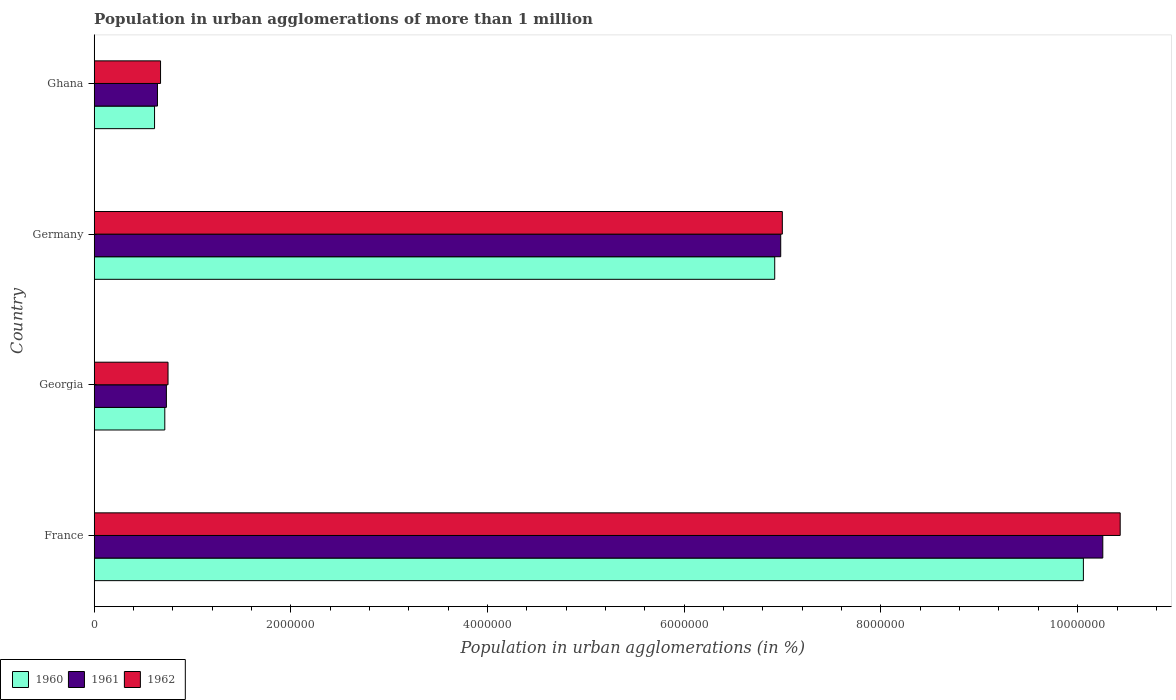How many different coloured bars are there?
Offer a terse response. 3. How many groups of bars are there?
Provide a succinct answer. 4. Are the number of bars per tick equal to the number of legend labels?
Make the answer very short. Yes. What is the population in urban agglomerations in 1962 in Georgia?
Your answer should be very brief. 7.51e+05. Across all countries, what is the maximum population in urban agglomerations in 1961?
Offer a very short reply. 1.03e+07. Across all countries, what is the minimum population in urban agglomerations in 1961?
Offer a terse response. 6.43e+05. What is the total population in urban agglomerations in 1961 in the graph?
Your answer should be compact. 1.86e+07. What is the difference between the population in urban agglomerations in 1960 in France and that in Georgia?
Offer a terse response. 9.34e+06. What is the difference between the population in urban agglomerations in 1962 in France and the population in urban agglomerations in 1961 in Georgia?
Offer a very short reply. 9.70e+06. What is the average population in urban agglomerations in 1960 per country?
Provide a short and direct response. 4.58e+06. What is the difference between the population in urban agglomerations in 1961 and population in urban agglomerations in 1962 in Georgia?
Offer a terse response. -1.66e+04. What is the ratio of the population in urban agglomerations in 1962 in Germany to that in Ghana?
Your response must be concise. 10.37. Is the population in urban agglomerations in 1961 in Georgia less than that in Germany?
Your answer should be very brief. Yes. What is the difference between the highest and the second highest population in urban agglomerations in 1960?
Your answer should be compact. 3.14e+06. What is the difference between the highest and the lowest population in urban agglomerations in 1960?
Give a very brief answer. 9.44e+06. Is it the case that in every country, the sum of the population in urban agglomerations in 1960 and population in urban agglomerations in 1961 is greater than the population in urban agglomerations in 1962?
Your answer should be very brief. Yes. Are all the bars in the graph horizontal?
Your response must be concise. Yes. How many countries are there in the graph?
Offer a terse response. 4. Are the values on the major ticks of X-axis written in scientific E-notation?
Your answer should be compact. No. Does the graph contain any zero values?
Your answer should be very brief. No. Where does the legend appear in the graph?
Provide a succinct answer. Bottom left. How are the legend labels stacked?
Your response must be concise. Horizontal. What is the title of the graph?
Your answer should be compact. Population in urban agglomerations of more than 1 million. Does "1980" appear as one of the legend labels in the graph?
Offer a very short reply. No. What is the label or title of the X-axis?
Make the answer very short. Population in urban agglomerations (in %). What is the label or title of the Y-axis?
Your answer should be very brief. Country. What is the Population in urban agglomerations (in %) in 1960 in France?
Your response must be concise. 1.01e+07. What is the Population in urban agglomerations (in %) of 1961 in France?
Offer a very short reply. 1.03e+07. What is the Population in urban agglomerations (in %) in 1962 in France?
Keep it short and to the point. 1.04e+07. What is the Population in urban agglomerations (in %) of 1960 in Georgia?
Keep it short and to the point. 7.18e+05. What is the Population in urban agglomerations (in %) in 1961 in Georgia?
Give a very brief answer. 7.34e+05. What is the Population in urban agglomerations (in %) in 1962 in Georgia?
Keep it short and to the point. 7.51e+05. What is the Population in urban agglomerations (in %) in 1960 in Germany?
Make the answer very short. 6.92e+06. What is the Population in urban agglomerations (in %) in 1961 in Germany?
Your answer should be very brief. 6.98e+06. What is the Population in urban agglomerations (in %) in 1962 in Germany?
Keep it short and to the point. 7.00e+06. What is the Population in urban agglomerations (in %) of 1960 in Ghana?
Your response must be concise. 6.14e+05. What is the Population in urban agglomerations (in %) in 1961 in Ghana?
Your answer should be very brief. 6.43e+05. What is the Population in urban agglomerations (in %) in 1962 in Ghana?
Keep it short and to the point. 6.75e+05. Across all countries, what is the maximum Population in urban agglomerations (in %) in 1960?
Offer a terse response. 1.01e+07. Across all countries, what is the maximum Population in urban agglomerations (in %) of 1961?
Your answer should be compact. 1.03e+07. Across all countries, what is the maximum Population in urban agglomerations (in %) in 1962?
Make the answer very short. 1.04e+07. Across all countries, what is the minimum Population in urban agglomerations (in %) of 1960?
Offer a terse response. 6.14e+05. Across all countries, what is the minimum Population in urban agglomerations (in %) in 1961?
Provide a succinct answer. 6.43e+05. Across all countries, what is the minimum Population in urban agglomerations (in %) of 1962?
Your response must be concise. 6.75e+05. What is the total Population in urban agglomerations (in %) in 1960 in the graph?
Offer a terse response. 1.83e+07. What is the total Population in urban agglomerations (in %) of 1961 in the graph?
Make the answer very short. 1.86e+07. What is the total Population in urban agglomerations (in %) in 1962 in the graph?
Keep it short and to the point. 1.89e+07. What is the difference between the Population in urban agglomerations (in %) in 1960 in France and that in Georgia?
Your answer should be compact. 9.34e+06. What is the difference between the Population in urban agglomerations (in %) of 1961 in France and that in Georgia?
Your answer should be very brief. 9.52e+06. What is the difference between the Population in urban agglomerations (in %) in 1962 in France and that in Georgia?
Keep it short and to the point. 9.68e+06. What is the difference between the Population in urban agglomerations (in %) in 1960 in France and that in Germany?
Keep it short and to the point. 3.14e+06. What is the difference between the Population in urban agglomerations (in %) of 1961 in France and that in Germany?
Your answer should be very brief. 3.28e+06. What is the difference between the Population in urban agglomerations (in %) in 1962 in France and that in Germany?
Offer a very short reply. 3.44e+06. What is the difference between the Population in urban agglomerations (in %) in 1960 in France and that in Ghana?
Offer a very short reply. 9.44e+06. What is the difference between the Population in urban agglomerations (in %) in 1961 in France and that in Ghana?
Your response must be concise. 9.61e+06. What is the difference between the Population in urban agglomerations (in %) of 1962 in France and that in Ghana?
Your answer should be very brief. 9.76e+06. What is the difference between the Population in urban agglomerations (in %) in 1960 in Georgia and that in Germany?
Provide a succinct answer. -6.20e+06. What is the difference between the Population in urban agglomerations (in %) of 1961 in Georgia and that in Germany?
Your answer should be very brief. -6.25e+06. What is the difference between the Population in urban agglomerations (in %) in 1962 in Georgia and that in Germany?
Provide a succinct answer. -6.25e+06. What is the difference between the Population in urban agglomerations (in %) in 1960 in Georgia and that in Ghana?
Offer a terse response. 1.04e+05. What is the difference between the Population in urban agglomerations (in %) of 1961 in Georgia and that in Ghana?
Your response must be concise. 9.06e+04. What is the difference between the Population in urban agglomerations (in %) of 1962 in Georgia and that in Ghana?
Your answer should be very brief. 7.60e+04. What is the difference between the Population in urban agglomerations (in %) of 1960 in Germany and that in Ghana?
Provide a short and direct response. 6.31e+06. What is the difference between the Population in urban agglomerations (in %) in 1961 in Germany and that in Ghana?
Give a very brief answer. 6.34e+06. What is the difference between the Population in urban agglomerations (in %) of 1962 in Germany and that in Ghana?
Ensure brevity in your answer.  6.32e+06. What is the difference between the Population in urban agglomerations (in %) of 1960 in France and the Population in urban agglomerations (in %) of 1961 in Georgia?
Give a very brief answer. 9.32e+06. What is the difference between the Population in urban agglomerations (in %) in 1960 in France and the Population in urban agglomerations (in %) in 1962 in Georgia?
Provide a short and direct response. 9.31e+06. What is the difference between the Population in urban agglomerations (in %) in 1961 in France and the Population in urban agglomerations (in %) in 1962 in Georgia?
Give a very brief answer. 9.50e+06. What is the difference between the Population in urban agglomerations (in %) of 1960 in France and the Population in urban agglomerations (in %) of 1961 in Germany?
Give a very brief answer. 3.08e+06. What is the difference between the Population in urban agglomerations (in %) of 1960 in France and the Population in urban agglomerations (in %) of 1962 in Germany?
Provide a succinct answer. 3.06e+06. What is the difference between the Population in urban agglomerations (in %) in 1961 in France and the Population in urban agglomerations (in %) in 1962 in Germany?
Your response must be concise. 3.26e+06. What is the difference between the Population in urban agglomerations (in %) in 1960 in France and the Population in urban agglomerations (in %) in 1961 in Ghana?
Make the answer very short. 9.41e+06. What is the difference between the Population in urban agglomerations (in %) of 1960 in France and the Population in urban agglomerations (in %) of 1962 in Ghana?
Make the answer very short. 9.38e+06. What is the difference between the Population in urban agglomerations (in %) in 1961 in France and the Population in urban agglomerations (in %) in 1962 in Ghana?
Your response must be concise. 9.58e+06. What is the difference between the Population in urban agglomerations (in %) of 1960 in Georgia and the Population in urban agglomerations (in %) of 1961 in Germany?
Provide a short and direct response. -6.26e+06. What is the difference between the Population in urban agglomerations (in %) in 1960 in Georgia and the Population in urban agglomerations (in %) in 1962 in Germany?
Your response must be concise. -6.28e+06. What is the difference between the Population in urban agglomerations (in %) in 1961 in Georgia and the Population in urban agglomerations (in %) in 1962 in Germany?
Keep it short and to the point. -6.26e+06. What is the difference between the Population in urban agglomerations (in %) in 1960 in Georgia and the Population in urban agglomerations (in %) in 1961 in Ghana?
Your response must be concise. 7.44e+04. What is the difference between the Population in urban agglomerations (in %) in 1960 in Georgia and the Population in urban agglomerations (in %) in 1962 in Ghana?
Provide a short and direct response. 4.31e+04. What is the difference between the Population in urban agglomerations (in %) of 1961 in Georgia and the Population in urban agglomerations (in %) of 1962 in Ghana?
Your answer should be very brief. 5.94e+04. What is the difference between the Population in urban agglomerations (in %) in 1960 in Germany and the Population in urban agglomerations (in %) in 1961 in Ghana?
Your response must be concise. 6.28e+06. What is the difference between the Population in urban agglomerations (in %) in 1960 in Germany and the Population in urban agglomerations (in %) in 1962 in Ghana?
Offer a terse response. 6.24e+06. What is the difference between the Population in urban agglomerations (in %) in 1961 in Germany and the Population in urban agglomerations (in %) in 1962 in Ghana?
Your response must be concise. 6.31e+06. What is the average Population in urban agglomerations (in %) of 1960 per country?
Provide a short and direct response. 4.58e+06. What is the average Population in urban agglomerations (in %) in 1961 per country?
Your answer should be very brief. 4.65e+06. What is the average Population in urban agglomerations (in %) in 1962 per country?
Provide a succinct answer. 4.71e+06. What is the difference between the Population in urban agglomerations (in %) in 1960 and Population in urban agglomerations (in %) in 1961 in France?
Offer a terse response. -1.97e+05. What is the difference between the Population in urban agglomerations (in %) in 1960 and Population in urban agglomerations (in %) in 1962 in France?
Provide a short and direct response. -3.74e+05. What is the difference between the Population in urban agglomerations (in %) in 1961 and Population in urban agglomerations (in %) in 1962 in France?
Provide a succinct answer. -1.77e+05. What is the difference between the Population in urban agglomerations (in %) of 1960 and Population in urban agglomerations (in %) of 1961 in Georgia?
Your response must be concise. -1.63e+04. What is the difference between the Population in urban agglomerations (in %) of 1960 and Population in urban agglomerations (in %) of 1962 in Georgia?
Ensure brevity in your answer.  -3.29e+04. What is the difference between the Population in urban agglomerations (in %) of 1961 and Population in urban agglomerations (in %) of 1962 in Georgia?
Give a very brief answer. -1.66e+04. What is the difference between the Population in urban agglomerations (in %) in 1960 and Population in urban agglomerations (in %) in 1961 in Germany?
Keep it short and to the point. -6.10e+04. What is the difference between the Population in urban agglomerations (in %) of 1960 and Population in urban agglomerations (in %) of 1962 in Germany?
Your response must be concise. -7.73e+04. What is the difference between the Population in urban agglomerations (in %) of 1961 and Population in urban agglomerations (in %) of 1962 in Germany?
Give a very brief answer. -1.64e+04. What is the difference between the Population in urban agglomerations (in %) of 1960 and Population in urban agglomerations (in %) of 1961 in Ghana?
Offer a terse response. -2.98e+04. What is the difference between the Population in urban agglomerations (in %) in 1960 and Population in urban agglomerations (in %) in 1962 in Ghana?
Offer a very short reply. -6.10e+04. What is the difference between the Population in urban agglomerations (in %) of 1961 and Population in urban agglomerations (in %) of 1962 in Ghana?
Provide a succinct answer. -3.12e+04. What is the ratio of the Population in urban agglomerations (in %) in 1960 in France to that in Georgia?
Ensure brevity in your answer.  14.01. What is the ratio of the Population in urban agglomerations (in %) of 1961 in France to that in Georgia?
Provide a succinct answer. 13.97. What is the ratio of the Population in urban agglomerations (in %) in 1962 in France to that in Georgia?
Keep it short and to the point. 13.9. What is the ratio of the Population in urban agglomerations (in %) of 1960 in France to that in Germany?
Offer a terse response. 1.45. What is the ratio of the Population in urban agglomerations (in %) of 1961 in France to that in Germany?
Make the answer very short. 1.47. What is the ratio of the Population in urban agglomerations (in %) of 1962 in France to that in Germany?
Your answer should be very brief. 1.49. What is the ratio of the Population in urban agglomerations (in %) of 1960 in France to that in Ghana?
Your answer should be compact. 16.39. What is the ratio of the Population in urban agglomerations (in %) in 1961 in France to that in Ghana?
Offer a very short reply. 15.94. What is the ratio of the Population in urban agglomerations (in %) of 1962 in France to that in Ghana?
Offer a terse response. 15.46. What is the ratio of the Population in urban agglomerations (in %) of 1960 in Georgia to that in Germany?
Your answer should be compact. 0.1. What is the ratio of the Population in urban agglomerations (in %) in 1961 in Georgia to that in Germany?
Your answer should be compact. 0.11. What is the ratio of the Population in urban agglomerations (in %) in 1962 in Georgia to that in Germany?
Provide a succinct answer. 0.11. What is the ratio of the Population in urban agglomerations (in %) of 1960 in Georgia to that in Ghana?
Offer a terse response. 1.17. What is the ratio of the Population in urban agglomerations (in %) in 1961 in Georgia to that in Ghana?
Ensure brevity in your answer.  1.14. What is the ratio of the Population in urban agglomerations (in %) of 1962 in Georgia to that in Ghana?
Your response must be concise. 1.11. What is the ratio of the Population in urban agglomerations (in %) in 1960 in Germany to that in Ghana?
Your response must be concise. 11.28. What is the ratio of the Population in urban agglomerations (in %) in 1961 in Germany to that in Ghana?
Provide a short and direct response. 10.85. What is the ratio of the Population in urban agglomerations (in %) of 1962 in Germany to that in Ghana?
Ensure brevity in your answer.  10.37. What is the difference between the highest and the second highest Population in urban agglomerations (in %) of 1960?
Your answer should be very brief. 3.14e+06. What is the difference between the highest and the second highest Population in urban agglomerations (in %) in 1961?
Your response must be concise. 3.28e+06. What is the difference between the highest and the second highest Population in urban agglomerations (in %) in 1962?
Your answer should be very brief. 3.44e+06. What is the difference between the highest and the lowest Population in urban agglomerations (in %) of 1960?
Keep it short and to the point. 9.44e+06. What is the difference between the highest and the lowest Population in urban agglomerations (in %) in 1961?
Make the answer very short. 9.61e+06. What is the difference between the highest and the lowest Population in urban agglomerations (in %) in 1962?
Your answer should be compact. 9.76e+06. 